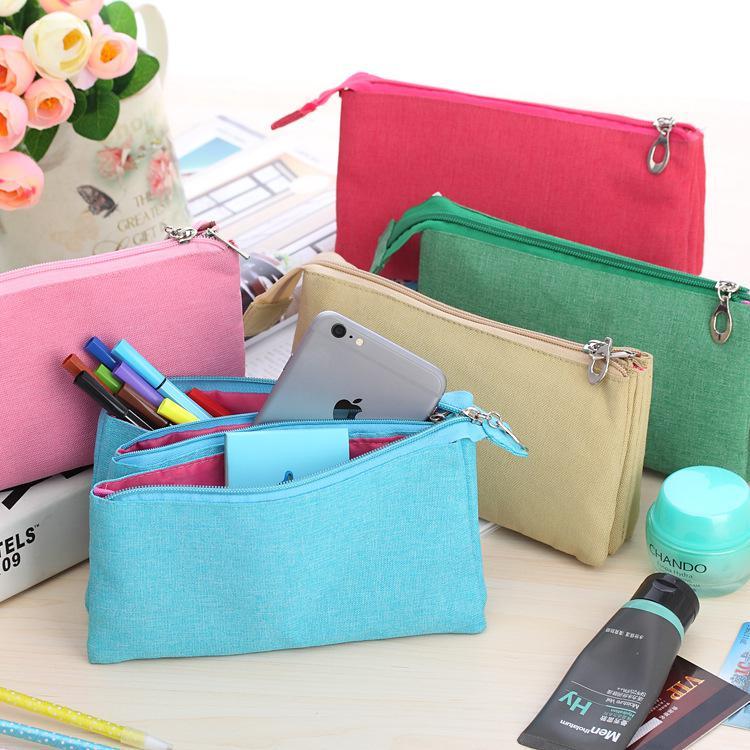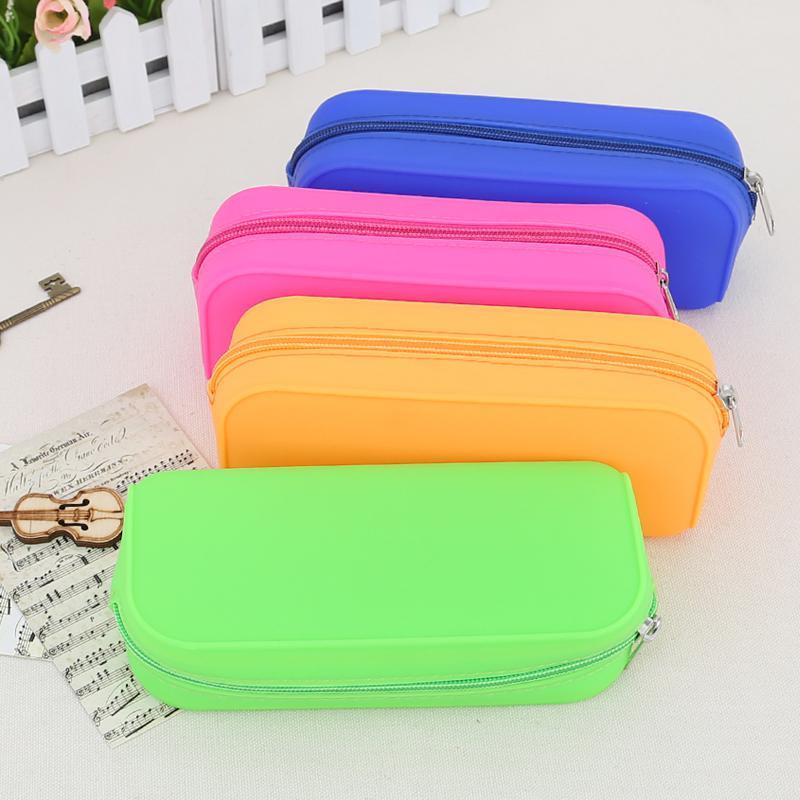The first image is the image on the left, the second image is the image on the right. Evaluate the accuracy of this statement regarding the images: "Contents are poking out of one of the bags in the image on the left.". Is it true? Answer yes or no. Yes. The first image is the image on the left, the second image is the image on the right. For the images displayed, is the sentence "One image shows exactly four closed pencil cases of different solid colors, designed with zippers that extend around rounded corners." factually correct? Answer yes or no. Yes. 